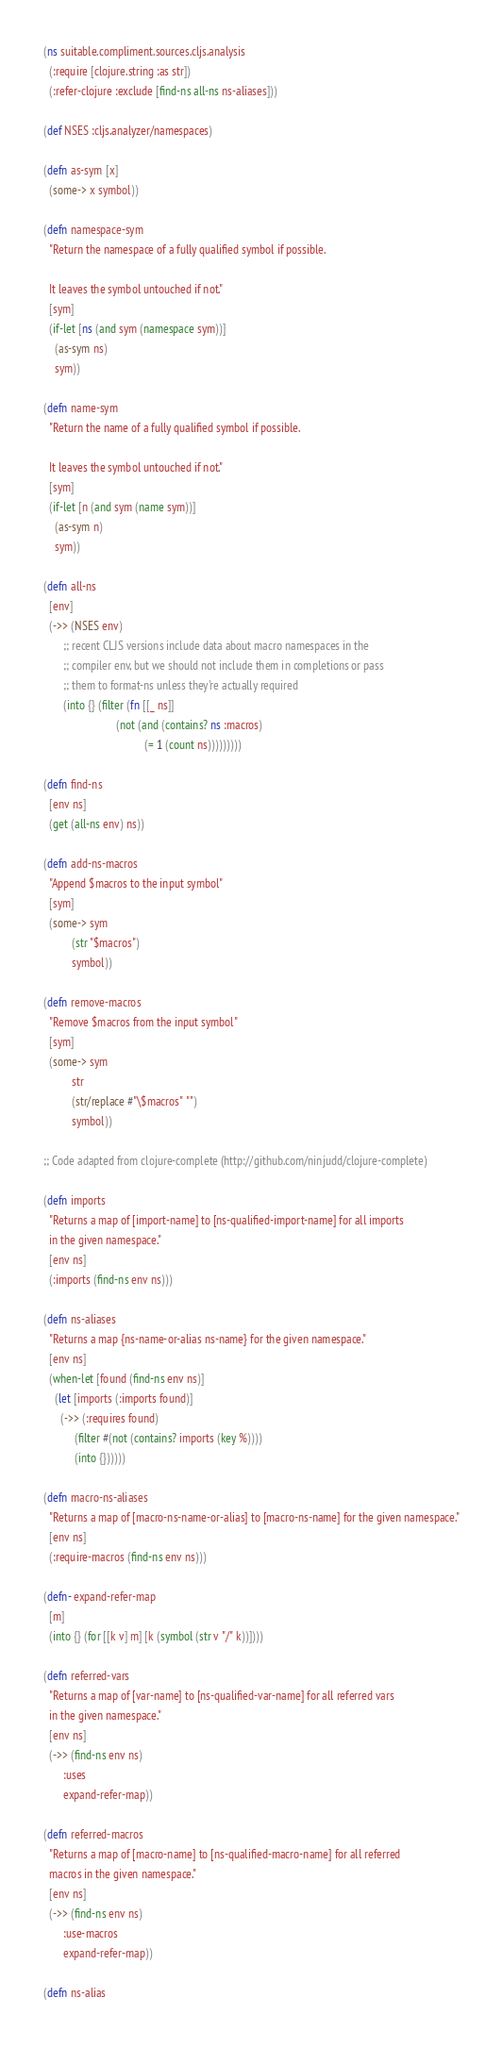<code> <loc_0><loc_0><loc_500><loc_500><_Clojure_>(ns suitable.compliment.sources.cljs.analysis
  (:require [clojure.string :as str])
  (:refer-clojure :exclude [find-ns all-ns ns-aliases]))

(def NSES :cljs.analyzer/namespaces)

(defn as-sym [x]
  (some-> x symbol))

(defn namespace-sym
  "Return the namespace of a fully qualified symbol if possible.

  It leaves the symbol untouched if not."
  [sym]
  (if-let [ns (and sym (namespace sym))]
    (as-sym ns)
    sym))

(defn name-sym
  "Return the name of a fully qualified symbol if possible.

  It leaves the symbol untouched if not."
  [sym]
  (if-let [n (and sym (name sym))]
    (as-sym n)
    sym))

(defn all-ns
  [env]
  (->> (NSES env)
       ;; recent CLJS versions include data about macro namespaces in the
       ;; compiler env, but we should not include them in completions or pass
       ;; them to format-ns unless they're actually required
       (into {} (filter (fn [[_ ns]]
                          (not (and (contains? ns :macros)
                                    (= 1 (count ns)))))))))

(defn find-ns
  [env ns]
  (get (all-ns env) ns))

(defn add-ns-macros
  "Append $macros to the input symbol"
  [sym]
  (some-> sym
          (str "$macros")
          symbol))

(defn remove-macros
  "Remove $macros from the input symbol"
  [sym]
  (some-> sym
          str
          (str/replace #"\$macros" "")
          symbol))

;; Code adapted from clojure-complete (http://github.com/ninjudd/clojure-complete)

(defn imports
  "Returns a map of [import-name] to [ns-qualified-import-name] for all imports
  in the given namespace."
  [env ns]
  (:imports (find-ns env ns)))

(defn ns-aliases
  "Returns a map {ns-name-or-alias ns-name} for the given namespace."
  [env ns]
  (when-let [found (find-ns env ns)]
    (let [imports (:imports found)]
      (->> (:requires found)
           (filter #(not (contains? imports (key %))))
           (into {})))))

(defn macro-ns-aliases
  "Returns a map of [macro-ns-name-or-alias] to [macro-ns-name] for the given namespace."
  [env ns]
  (:require-macros (find-ns env ns)))

(defn- expand-refer-map
  [m]
  (into {} (for [[k v] m] [k (symbol (str v "/" k))])))

(defn referred-vars
  "Returns a map of [var-name] to [ns-qualified-var-name] for all referred vars
  in the given namespace."
  [env ns]
  (->> (find-ns env ns)
       :uses
       expand-refer-map))

(defn referred-macros
  "Returns a map of [macro-name] to [ns-qualified-macro-name] for all referred
  macros in the given namespace."
  [env ns]
  (->> (find-ns env ns)
       :use-macros
       expand-refer-map))

(defn ns-alias</code> 